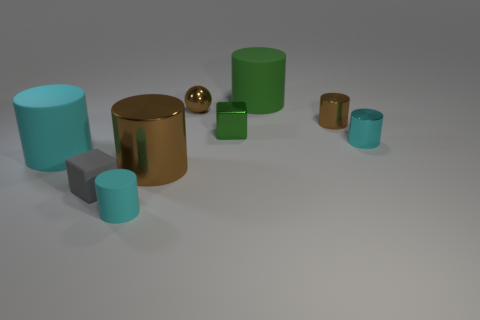Do the gray rubber cube and the cyan object that is to the left of the gray rubber cube have the same size?
Your answer should be compact. No. What number of rubber objects are either small cyan cylinders or green cubes?
Your answer should be compact. 1. Are there more green metal objects than purple shiny objects?
Keep it short and to the point. Yes. There is a rubber object that is the same color as the small metallic block; what size is it?
Offer a terse response. Large. There is a cyan matte object in front of the cyan cylinder that is on the left side of the tiny cyan matte cylinder; what is its shape?
Provide a succinct answer. Cylinder. Are there any big metal things to the right of the brown shiny ball to the left of the tiny brown metal object right of the small green block?
Make the answer very short. No. There is a shiny block that is the same size as the gray matte block; what color is it?
Keep it short and to the point. Green. What shape is the small thing that is both behind the tiny matte cylinder and on the left side of the brown shiny sphere?
Make the answer very short. Cube. There is a gray cube that is behind the tiny cyan thing that is left of the tiny metal block; what size is it?
Provide a short and direct response. Small. What number of cylinders are the same color as the tiny sphere?
Offer a very short reply. 2. 